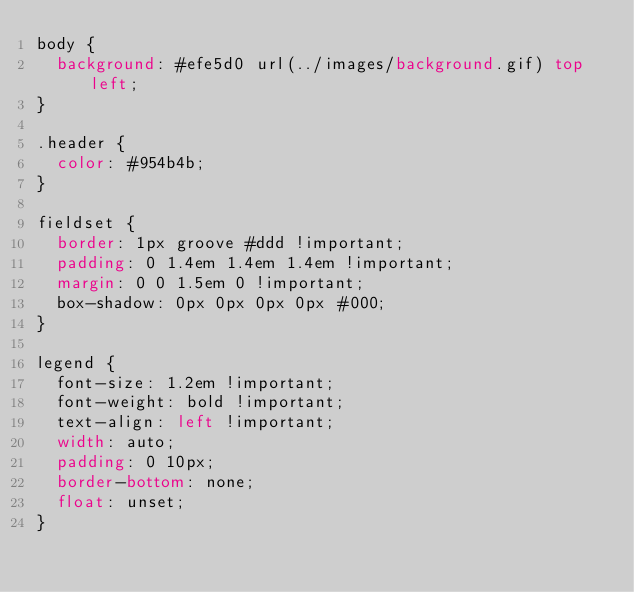Convert code to text. <code><loc_0><loc_0><loc_500><loc_500><_CSS_>body {
  background: #efe5d0 url(../images/background.gif) top left;
}

.header {
  color: #954b4b;
}

fieldset {
  border: 1px groove #ddd !important;
  padding: 0 1.4em 1.4em 1.4em !important;
  margin: 0 0 1.5em 0 !important;
  box-shadow: 0px 0px 0px 0px #000;
}

legend {
  font-size: 1.2em !important;
  font-weight: bold !important;
  text-align: left !important;
  width: auto;
  padding: 0 10px;
  border-bottom: none;
  float: unset;
}
</code> 